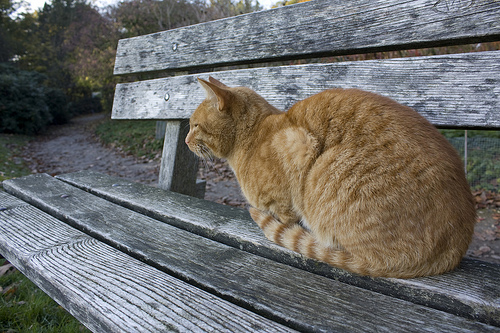What is under the bench that is in front of the path? Under the bench that is in front of the path, there is grass. 